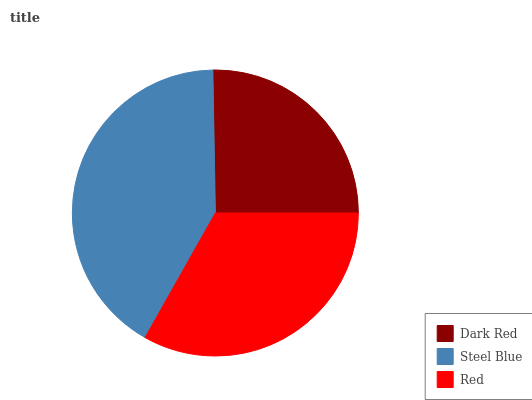Is Dark Red the minimum?
Answer yes or no. Yes. Is Steel Blue the maximum?
Answer yes or no. Yes. Is Red the minimum?
Answer yes or no. No. Is Red the maximum?
Answer yes or no. No. Is Steel Blue greater than Red?
Answer yes or no. Yes. Is Red less than Steel Blue?
Answer yes or no. Yes. Is Red greater than Steel Blue?
Answer yes or no. No. Is Steel Blue less than Red?
Answer yes or no. No. Is Red the high median?
Answer yes or no. Yes. Is Red the low median?
Answer yes or no. Yes. Is Dark Red the high median?
Answer yes or no. No. Is Dark Red the low median?
Answer yes or no. No. 